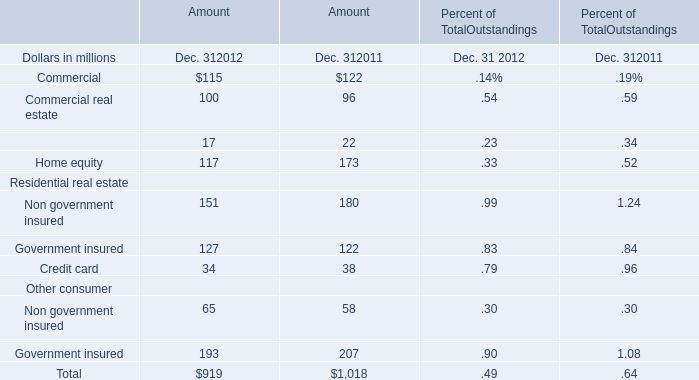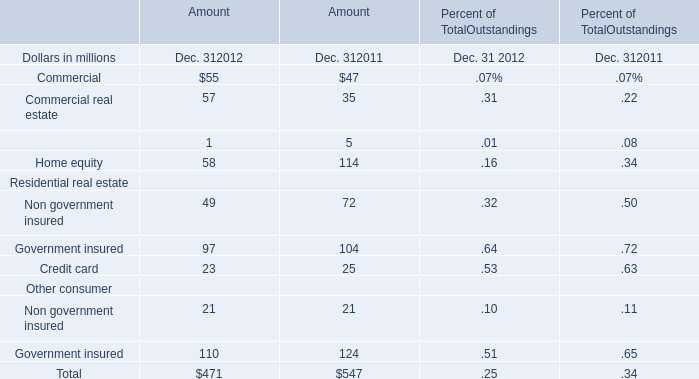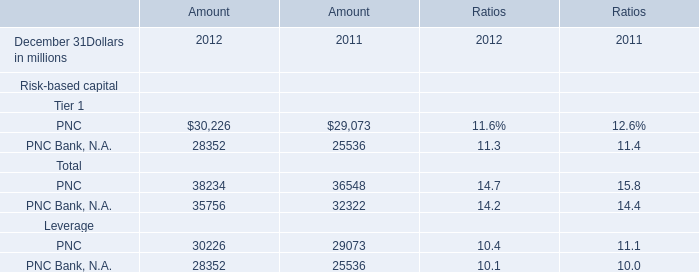What's the average of Residential real estate in 2012? (in million) 
Computations: (((49 + 97) + 23) / 3)
Answer: 56.33333. 